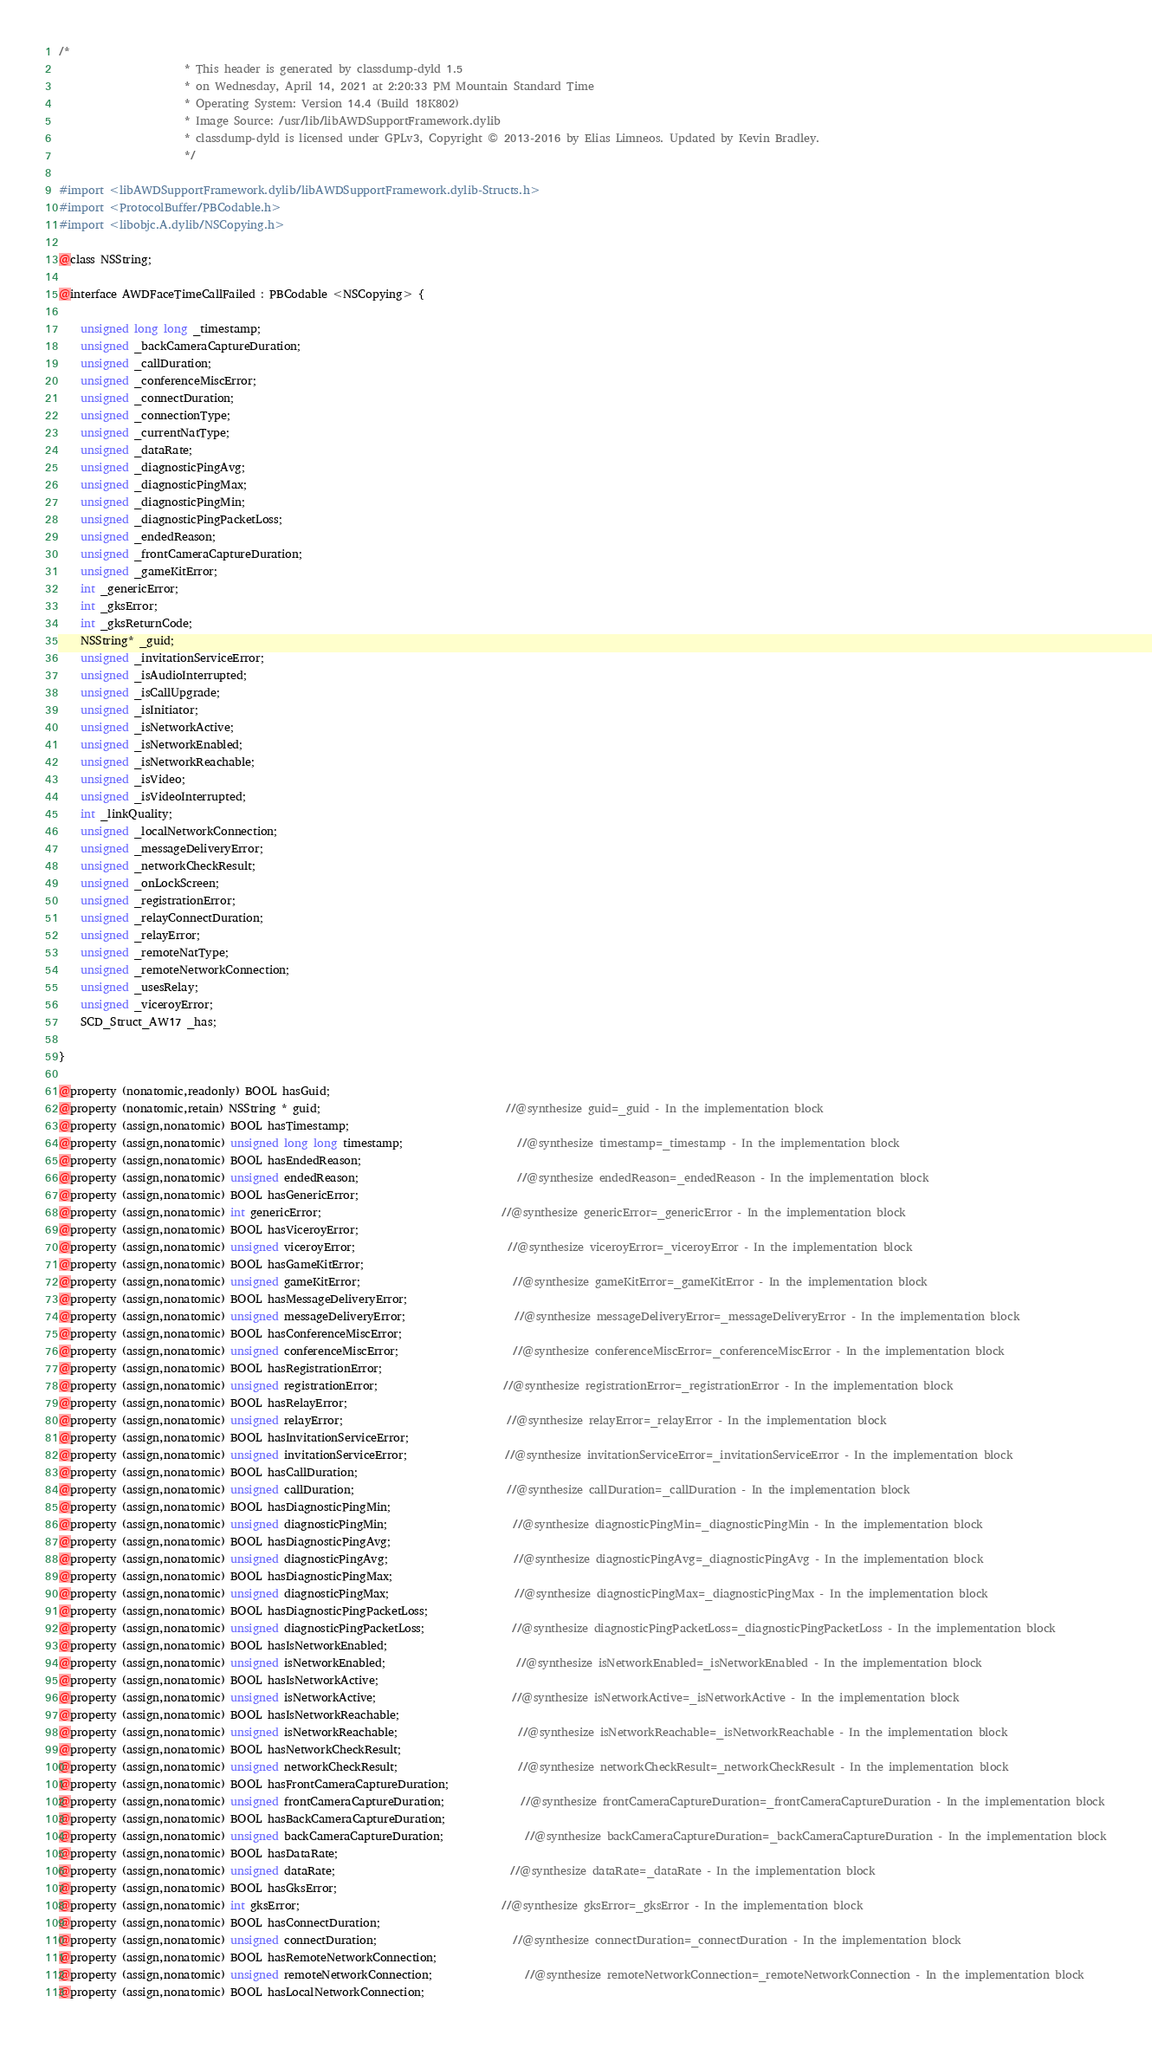<code> <loc_0><loc_0><loc_500><loc_500><_C_>/*
                       * This header is generated by classdump-dyld 1.5
                       * on Wednesday, April 14, 2021 at 2:20:33 PM Mountain Standard Time
                       * Operating System: Version 14.4 (Build 18K802)
                       * Image Source: /usr/lib/libAWDSupportFramework.dylib
                       * classdump-dyld is licensed under GPLv3, Copyright © 2013-2016 by Elias Limneos. Updated by Kevin Bradley.
                       */

#import <libAWDSupportFramework.dylib/libAWDSupportFramework.dylib-Structs.h>
#import <ProtocolBuffer/PBCodable.h>
#import <libobjc.A.dylib/NSCopying.h>

@class NSString;

@interface AWDFaceTimeCallFailed : PBCodable <NSCopying> {

	unsigned long long _timestamp;
	unsigned _backCameraCaptureDuration;
	unsigned _callDuration;
	unsigned _conferenceMiscError;
	unsigned _connectDuration;
	unsigned _connectionType;
	unsigned _currentNatType;
	unsigned _dataRate;
	unsigned _diagnosticPingAvg;
	unsigned _diagnosticPingMax;
	unsigned _diagnosticPingMin;
	unsigned _diagnosticPingPacketLoss;
	unsigned _endedReason;
	unsigned _frontCameraCaptureDuration;
	unsigned _gameKitError;
	int _genericError;
	int _gksError;
	int _gksReturnCode;
	NSString* _guid;
	unsigned _invitationServiceError;
	unsigned _isAudioInterrupted;
	unsigned _isCallUpgrade;
	unsigned _isInitiator;
	unsigned _isNetworkActive;
	unsigned _isNetworkEnabled;
	unsigned _isNetworkReachable;
	unsigned _isVideo;
	unsigned _isVideoInterrupted;
	int _linkQuality;
	unsigned _localNetworkConnection;
	unsigned _messageDeliveryError;
	unsigned _networkCheckResult;
	unsigned _onLockScreen;
	unsigned _registrationError;
	unsigned _relayConnectDuration;
	unsigned _relayError;
	unsigned _remoteNatType;
	unsigned _remoteNetworkConnection;
	unsigned _usesRelay;
	unsigned _viceroyError;
	SCD_Struct_AW17 _has;

}

@property (nonatomic,readonly) BOOL hasGuid; 
@property (nonatomic,retain) NSString * guid;                                  //@synthesize guid=_guid - In the implementation block
@property (assign,nonatomic) BOOL hasTimestamp; 
@property (assign,nonatomic) unsigned long long timestamp;                     //@synthesize timestamp=_timestamp - In the implementation block
@property (assign,nonatomic) BOOL hasEndedReason; 
@property (assign,nonatomic) unsigned endedReason;                             //@synthesize endedReason=_endedReason - In the implementation block
@property (assign,nonatomic) BOOL hasGenericError; 
@property (assign,nonatomic) int genericError;                                 //@synthesize genericError=_genericError - In the implementation block
@property (assign,nonatomic) BOOL hasViceroyError; 
@property (assign,nonatomic) unsigned viceroyError;                            //@synthesize viceroyError=_viceroyError - In the implementation block
@property (assign,nonatomic) BOOL hasGameKitError; 
@property (assign,nonatomic) unsigned gameKitError;                            //@synthesize gameKitError=_gameKitError - In the implementation block
@property (assign,nonatomic) BOOL hasMessageDeliveryError; 
@property (assign,nonatomic) unsigned messageDeliveryError;                    //@synthesize messageDeliveryError=_messageDeliveryError - In the implementation block
@property (assign,nonatomic) BOOL hasConferenceMiscError; 
@property (assign,nonatomic) unsigned conferenceMiscError;                     //@synthesize conferenceMiscError=_conferenceMiscError - In the implementation block
@property (assign,nonatomic) BOOL hasRegistrationError; 
@property (assign,nonatomic) unsigned registrationError;                       //@synthesize registrationError=_registrationError - In the implementation block
@property (assign,nonatomic) BOOL hasRelayError; 
@property (assign,nonatomic) unsigned relayError;                              //@synthesize relayError=_relayError - In the implementation block
@property (assign,nonatomic) BOOL hasInvitationServiceError; 
@property (assign,nonatomic) unsigned invitationServiceError;                  //@synthesize invitationServiceError=_invitationServiceError - In the implementation block
@property (assign,nonatomic) BOOL hasCallDuration; 
@property (assign,nonatomic) unsigned callDuration;                            //@synthesize callDuration=_callDuration - In the implementation block
@property (assign,nonatomic) BOOL hasDiagnosticPingMin; 
@property (assign,nonatomic) unsigned diagnosticPingMin;                       //@synthesize diagnosticPingMin=_diagnosticPingMin - In the implementation block
@property (assign,nonatomic) BOOL hasDiagnosticPingAvg; 
@property (assign,nonatomic) unsigned diagnosticPingAvg;                       //@synthesize diagnosticPingAvg=_diagnosticPingAvg - In the implementation block
@property (assign,nonatomic) BOOL hasDiagnosticPingMax; 
@property (assign,nonatomic) unsigned diagnosticPingMax;                       //@synthesize diagnosticPingMax=_diagnosticPingMax - In the implementation block
@property (assign,nonatomic) BOOL hasDiagnosticPingPacketLoss; 
@property (assign,nonatomic) unsigned diagnosticPingPacketLoss;                //@synthesize diagnosticPingPacketLoss=_diagnosticPingPacketLoss - In the implementation block
@property (assign,nonatomic) BOOL hasIsNetworkEnabled; 
@property (assign,nonatomic) unsigned isNetworkEnabled;                        //@synthesize isNetworkEnabled=_isNetworkEnabled - In the implementation block
@property (assign,nonatomic) BOOL hasIsNetworkActive; 
@property (assign,nonatomic) unsigned isNetworkActive;                         //@synthesize isNetworkActive=_isNetworkActive - In the implementation block
@property (assign,nonatomic) BOOL hasIsNetworkReachable; 
@property (assign,nonatomic) unsigned isNetworkReachable;                      //@synthesize isNetworkReachable=_isNetworkReachable - In the implementation block
@property (assign,nonatomic) BOOL hasNetworkCheckResult; 
@property (assign,nonatomic) unsigned networkCheckResult;                      //@synthesize networkCheckResult=_networkCheckResult - In the implementation block
@property (assign,nonatomic) BOOL hasFrontCameraCaptureDuration; 
@property (assign,nonatomic) unsigned frontCameraCaptureDuration;              //@synthesize frontCameraCaptureDuration=_frontCameraCaptureDuration - In the implementation block
@property (assign,nonatomic) BOOL hasBackCameraCaptureDuration; 
@property (assign,nonatomic) unsigned backCameraCaptureDuration;               //@synthesize backCameraCaptureDuration=_backCameraCaptureDuration - In the implementation block
@property (assign,nonatomic) BOOL hasDataRate; 
@property (assign,nonatomic) unsigned dataRate;                                //@synthesize dataRate=_dataRate - In the implementation block
@property (assign,nonatomic) BOOL hasGksError; 
@property (assign,nonatomic) int gksError;                                     //@synthesize gksError=_gksError - In the implementation block
@property (assign,nonatomic) BOOL hasConnectDuration; 
@property (assign,nonatomic) unsigned connectDuration;                         //@synthesize connectDuration=_connectDuration - In the implementation block
@property (assign,nonatomic) BOOL hasRemoteNetworkConnection; 
@property (assign,nonatomic) unsigned remoteNetworkConnection;                 //@synthesize remoteNetworkConnection=_remoteNetworkConnection - In the implementation block
@property (assign,nonatomic) BOOL hasLocalNetworkConnection; </code> 